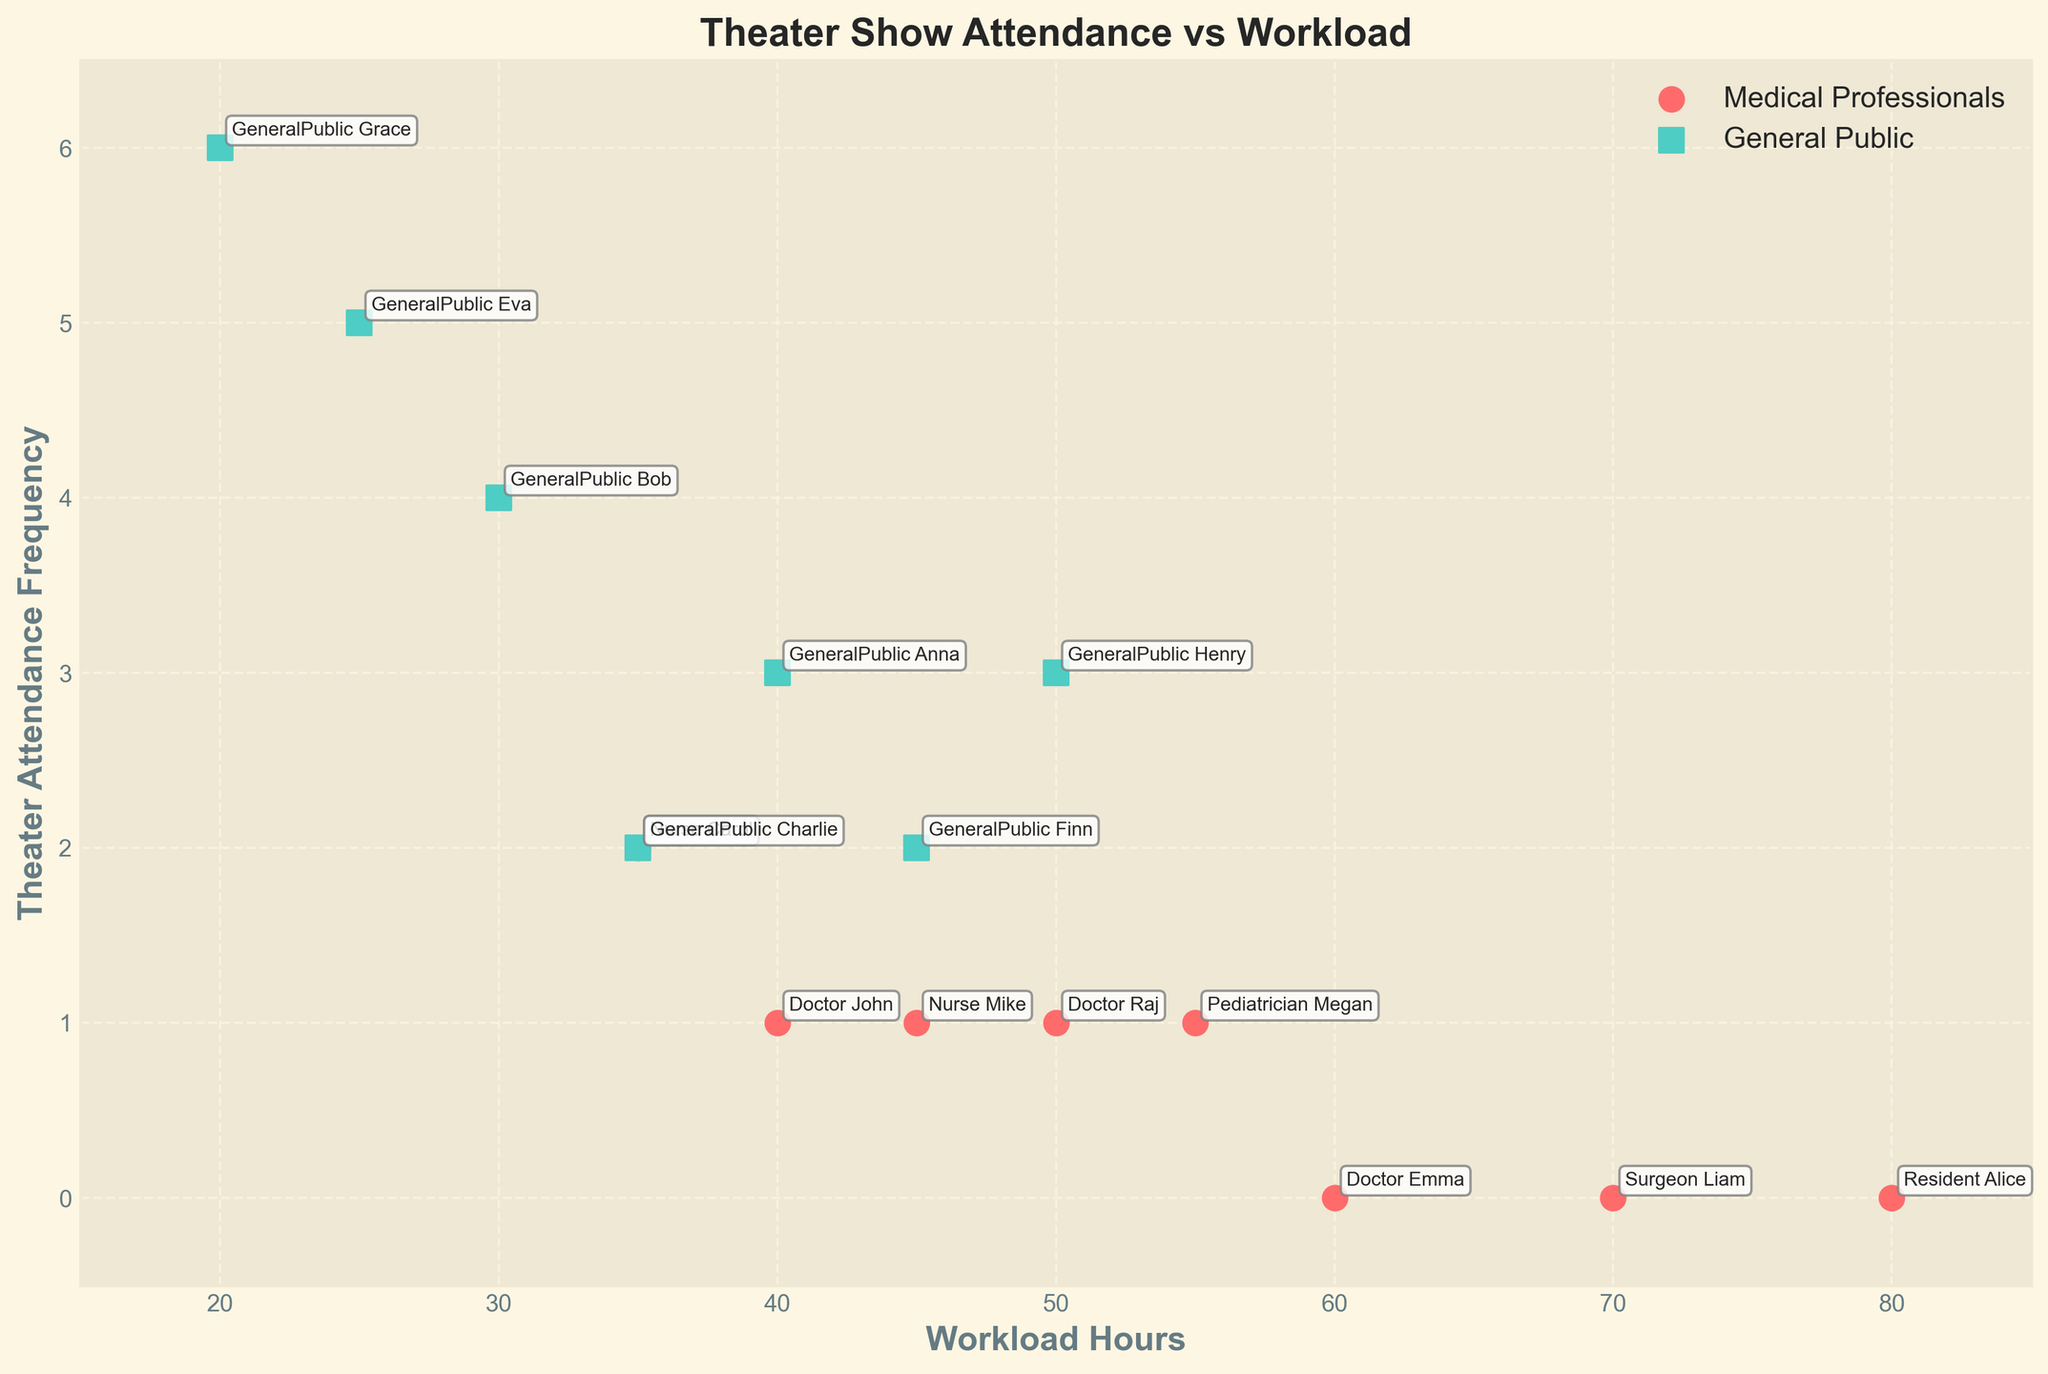What's the title of the plot? The title of the plot is displayed at the top center of the plot. It reads "Theater Show Attendance vs Workload".
Answer: Theater Show Attendance vs Workload What are the axis labels on the plot? The x-axis label is "Workload Hours" and the y-axis label is "Theater Attendance Frequency", which are written in bold and easily visible near the respective axes.
Answer: Workload Hours (x-axis) and Theater Attendance Frequency (y-axis) How many data points represent medical professionals? The scatter plot uses circles to show data points for medical professionals. By counting the number of circles, we can see there are 8 data points.
Answer: 8 What is the theater attendance frequency for Surgeon Liam and how does it compare to Resident Alice? Both Surgeon Liam and Resident Alice attendance frequencies are highlighted with a specific label on the plot. Surgeon Liam has an attendance frequency of 0 while Resident Alice also has 0.
Answer: 0, 0 Which group generally has higher theater attendance, medical professionals or the general public? By comparing the positions of the data points related to medical professionals (red circles) and the general public (green squares), green squares are generally higher on the y-axis, indicating higher attendance by the general public.
Answer: General public What is the workload range of the general public attending theater shows? To determine the range, check the general public data points represented by green squares on the x-axis. The minimum workload is 20 hours and the maximum is 50 hours.
Answer: 20 to 50 hours What's the average theater attendance frequency for Pediatrician Megan and Nurse Carol? Pediatrician Megan has an attendance frequency of 1 and Nurse Carol has 2. The average is calculated by summing these and dividing by the number of individuals: (1 + 2) / 2 = 1.5.
Answer: 1.5 Is there any general public data point above an attendance frequency of 5? The plot shows general public data points (green squares), and one of them reaches an attendance frequency of 6 (GeneralPublic Grace).
Answer: Yes Who has the highest theater attendance frequency and what is the corresponding workload hours? The plot labels each point, and the highest theater attendance frequency is 6 shown for GeneralPublic Grace, with a workload of 20 hours.
Answer: GeneralPublic Grace, 20 hours 